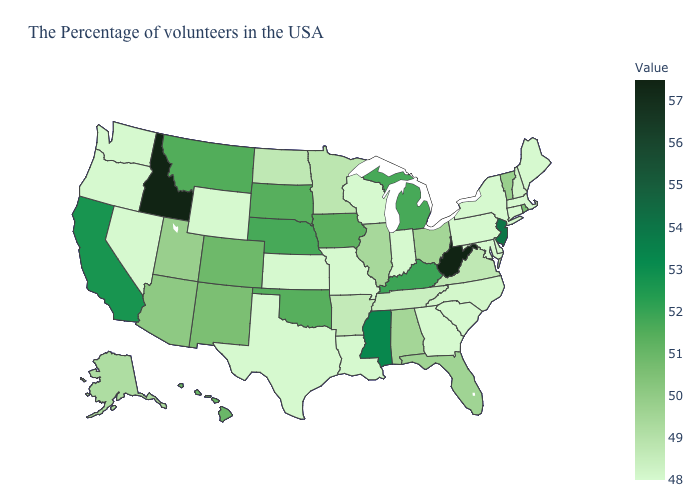Among the states that border Illinois , which have the lowest value?
Be succinct. Indiana, Wisconsin, Missouri. Among the states that border New Jersey , which have the highest value?
Write a very short answer. New York, Delaware, Pennsylvania. Is the legend a continuous bar?
Be succinct. Yes. Among the states that border Illinois , which have the highest value?
Short answer required. Kentucky. Does Mississippi have a lower value than Idaho?
Quick response, please. Yes. 